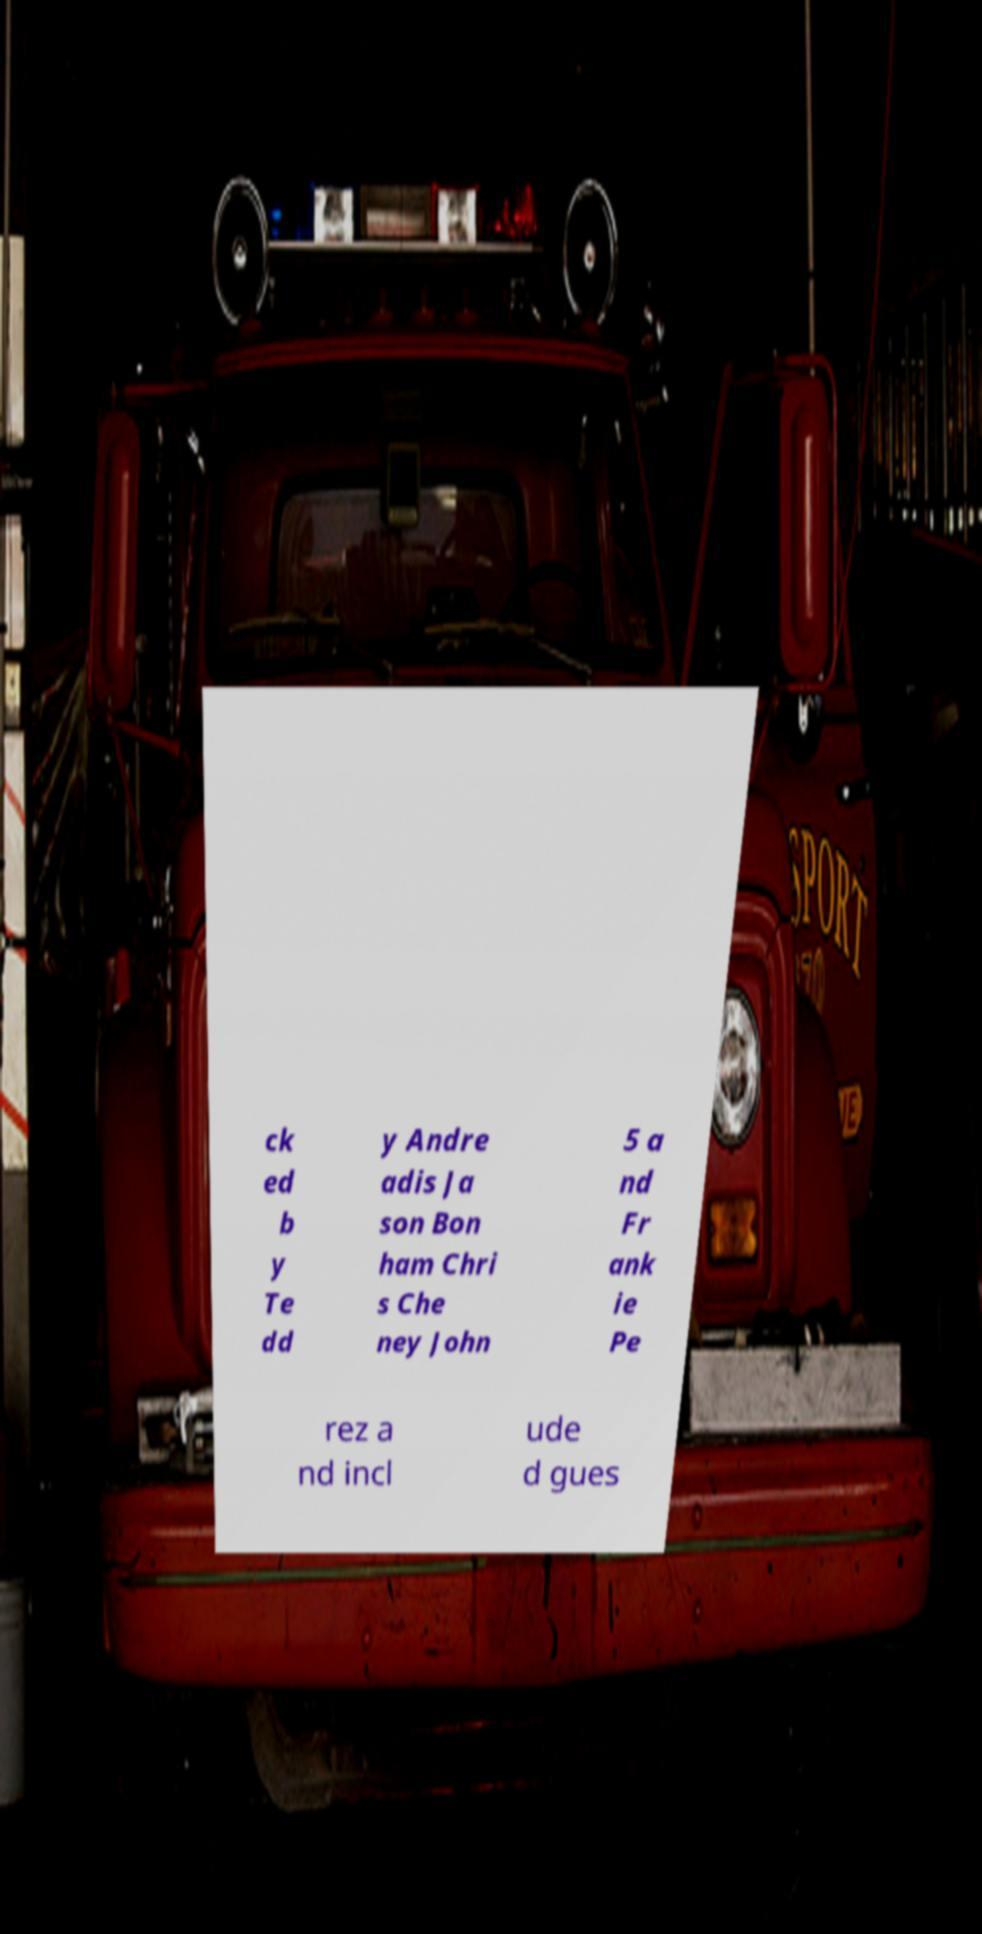Please read and relay the text visible in this image. What does it say? ck ed b y Te dd y Andre adis Ja son Bon ham Chri s Che ney John 5 a nd Fr ank ie Pe rez a nd incl ude d gues 